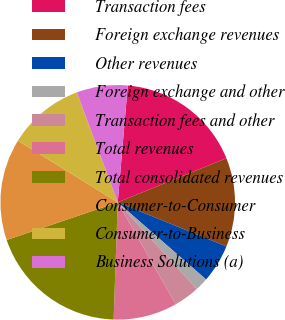Convert chart. <chart><loc_0><loc_0><loc_500><loc_500><pie_chart><fcel>Transaction fees<fcel>Foreign exchange revenues<fcel>Other revenues<fcel>Foreign exchange and other<fcel>Transaction fees and other<fcel>Total revenues<fcel>Total consolidated revenues<fcel>Consumer-to-Consumer<fcel>Consumer-to-Business<fcel>Business Solutions (a)<nl><fcel>17.5%<fcel>12.27%<fcel>5.29%<fcel>1.8%<fcel>3.55%<fcel>8.78%<fcel>19.24%<fcel>14.01%<fcel>10.52%<fcel>7.04%<nl></chart> 